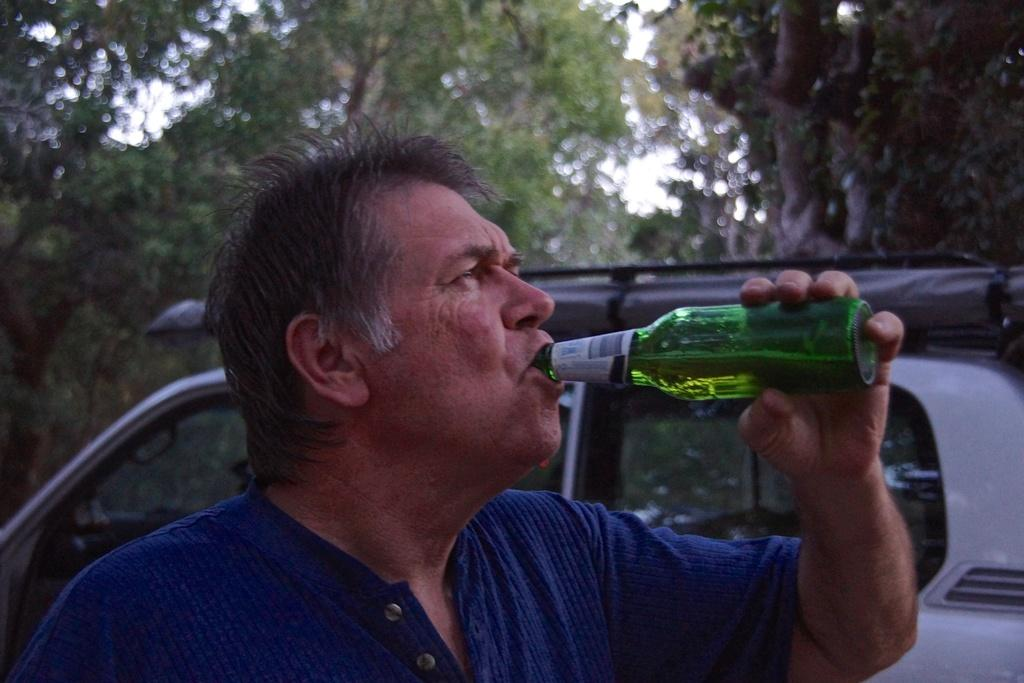Who is present in the image? There is a man in the image. What is the man holding in the image? The man is holding a bottle. What is the man doing with the bottle? The man is drinking from the bottle. What can be seen in the background of the image? There is a vehicle and trees visible in the background, as well as the sky. What type of throne is the man sitting on in the image? There is no throne present in the image; the man is standing and holding a bottle. 